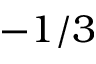<formula> <loc_0><loc_0><loc_500><loc_500>- 1 / 3</formula> 